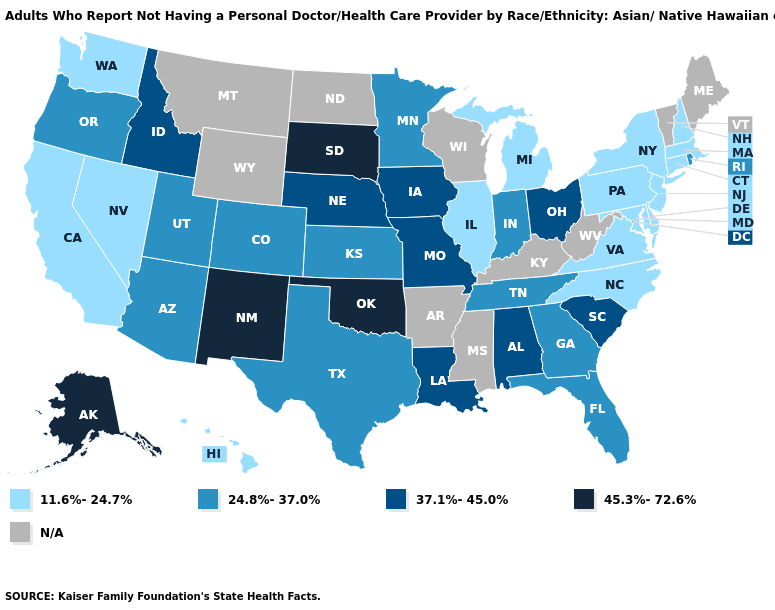What is the value of Alabama?
Give a very brief answer. 37.1%-45.0%. Which states hav the highest value in the Northeast?
Be succinct. Rhode Island. Name the states that have a value in the range 24.8%-37.0%?
Concise answer only. Arizona, Colorado, Florida, Georgia, Indiana, Kansas, Minnesota, Oregon, Rhode Island, Tennessee, Texas, Utah. Name the states that have a value in the range 37.1%-45.0%?
Give a very brief answer. Alabama, Idaho, Iowa, Louisiana, Missouri, Nebraska, Ohio, South Carolina. What is the lowest value in the Northeast?
Concise answer only. 11.6%-24.7%. Does Indiana have the lowest value in the USA?
Concise answer only. No. Does Iowa have the lowest value in the USA?
Concise answer only. No. Name the states that have a value in the range 37.1%-45.0%?
Quick response, please. Alabama, Idaho, Iowa, Louisiana, Missouri, Nebraska, Ohio, South Carolina. Does Indiana have the lowest value in the MidWest?
Give a very brief answer. No. What is the value of Mississippi?
Be succinct. N/A. Which states hav the highest value in the West?
Keep it brief. Alaska, New Mexico. Is the legend a continuous bar?
Concise answer only. No. What is the highest value in the USA?
Concise answer only. 45.3%-72.6%. What is the value of Oregon?
Give a very brief answer. 24.8%-37.0%. 